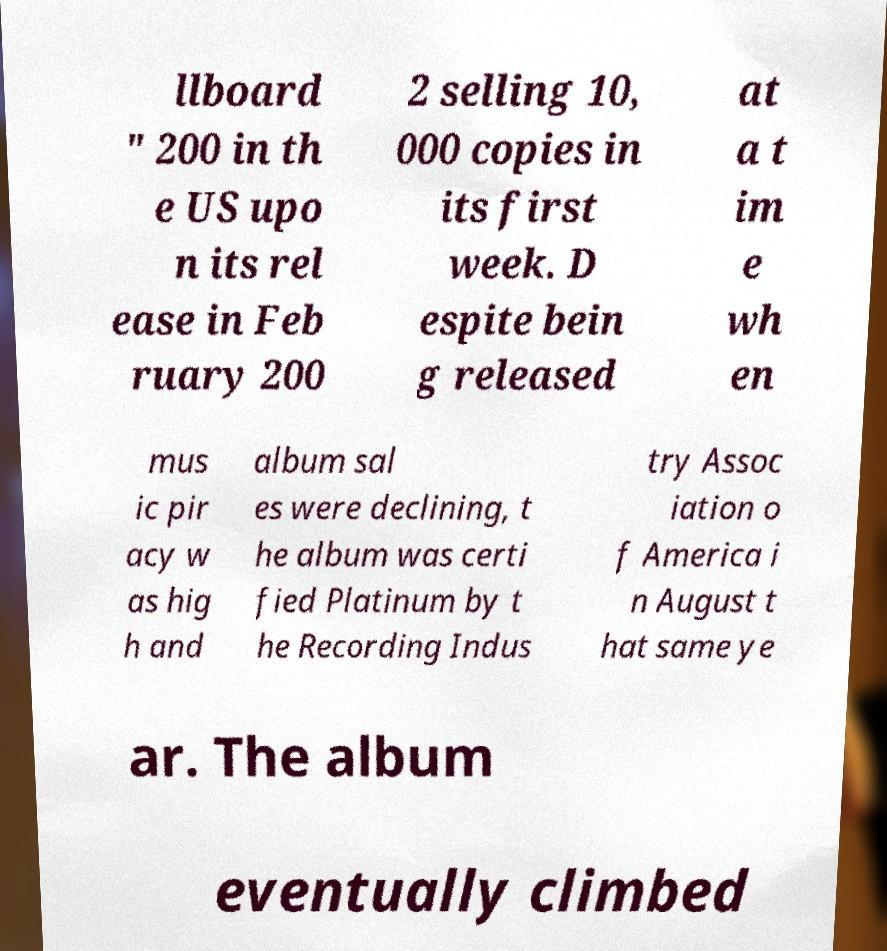Can you accurately transcribe the text from the provided image for me? llboard " 200 in th e US upo n its rel ease in Feb ruary 200 2 selling 10, 000 copies in its first week. D espite bein g released at a t im e wh en mus ic pir acy w as hig h and album sal es were declining, t he album was certi fied Platinum by t he Recording Indus try Assoc iation o f America i n August t hat same ye ar. The album eventually climbed 